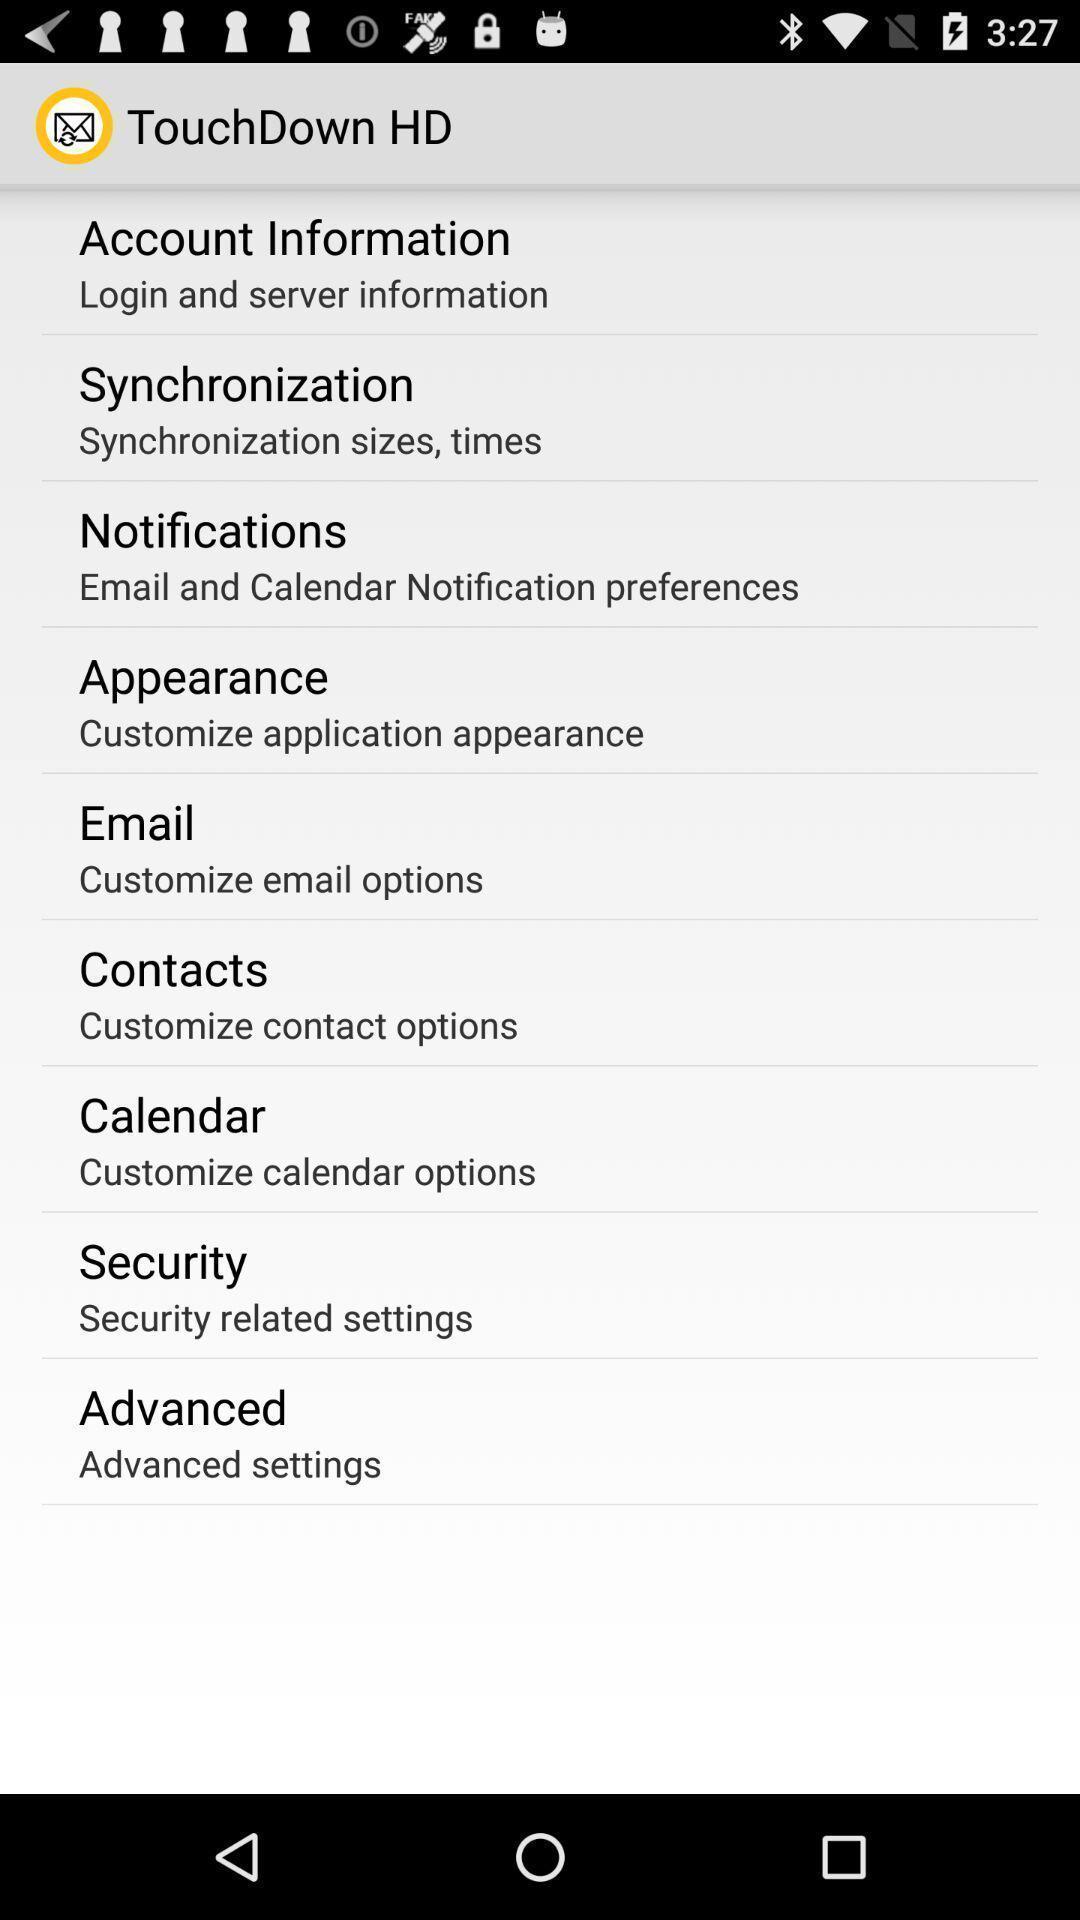Describe the visual elements of this screenshot. Settings page on an application with various options. 